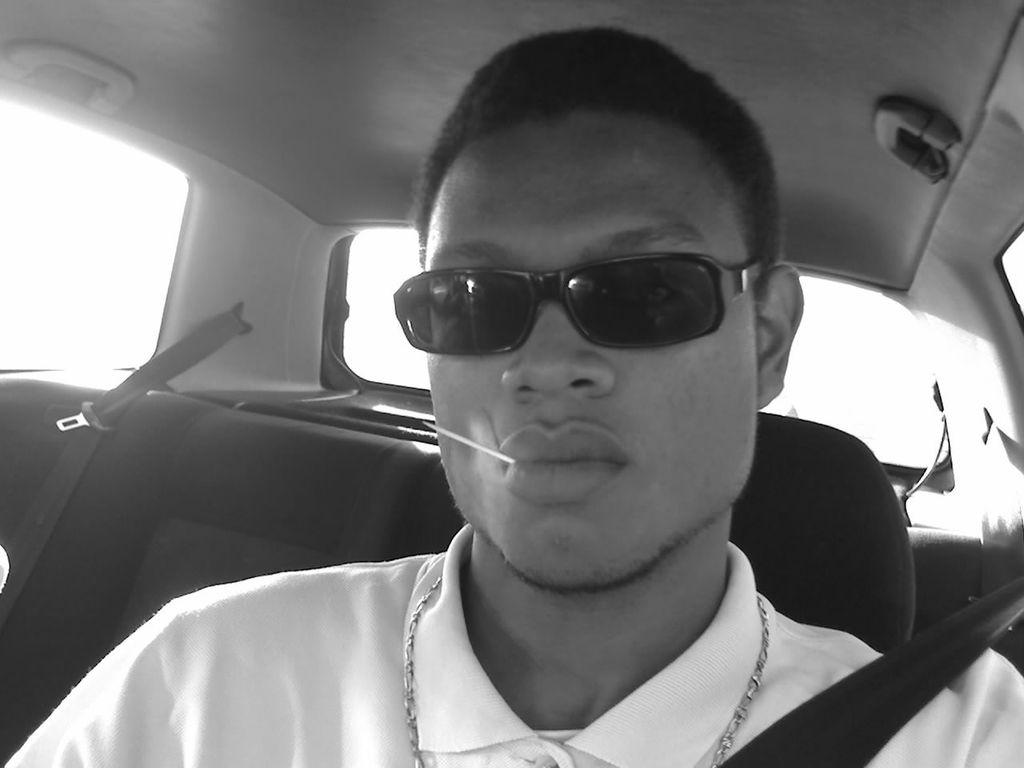What is the main subject in the foreground of the image? There is a person sitting in a car in the foreground of the image. What is the person wearing in the image? The person is wearing goggles. What can be seen in the background of the image? There is a window visible in the background of the image. What type of view does the image provide? The image is an inside view of a car. What type of fact can be seen on the earth in the image? There is no reference to a fact or the earth in the image; it features a person sitting in a car. How does the ice affect the visibility of the person in the image? There is no ice present in the image, so it does not affect the visibility of the person. 